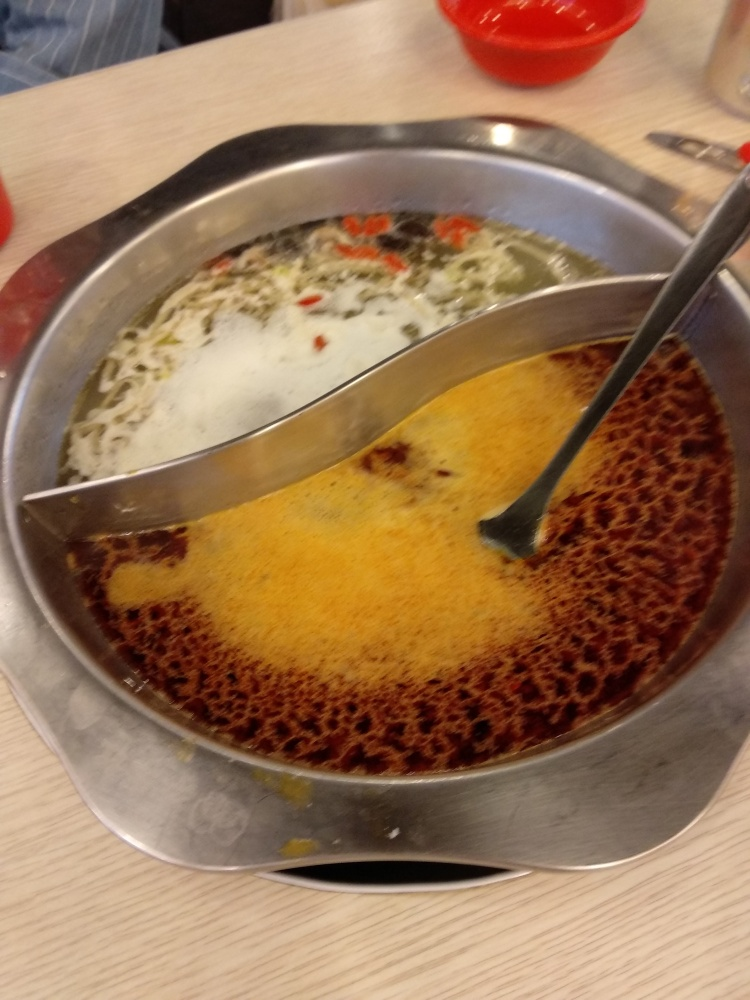Describe the ingredients visible in the hot pot. From the image, there are a variety of ingredients floating in the broths. On the clear side, I can see some greens and presumably some tofu or vegetables, while the spicy side contains some seeds, possibly from chilis or other spices that give it a reddish color and likely a fiery flavor. 